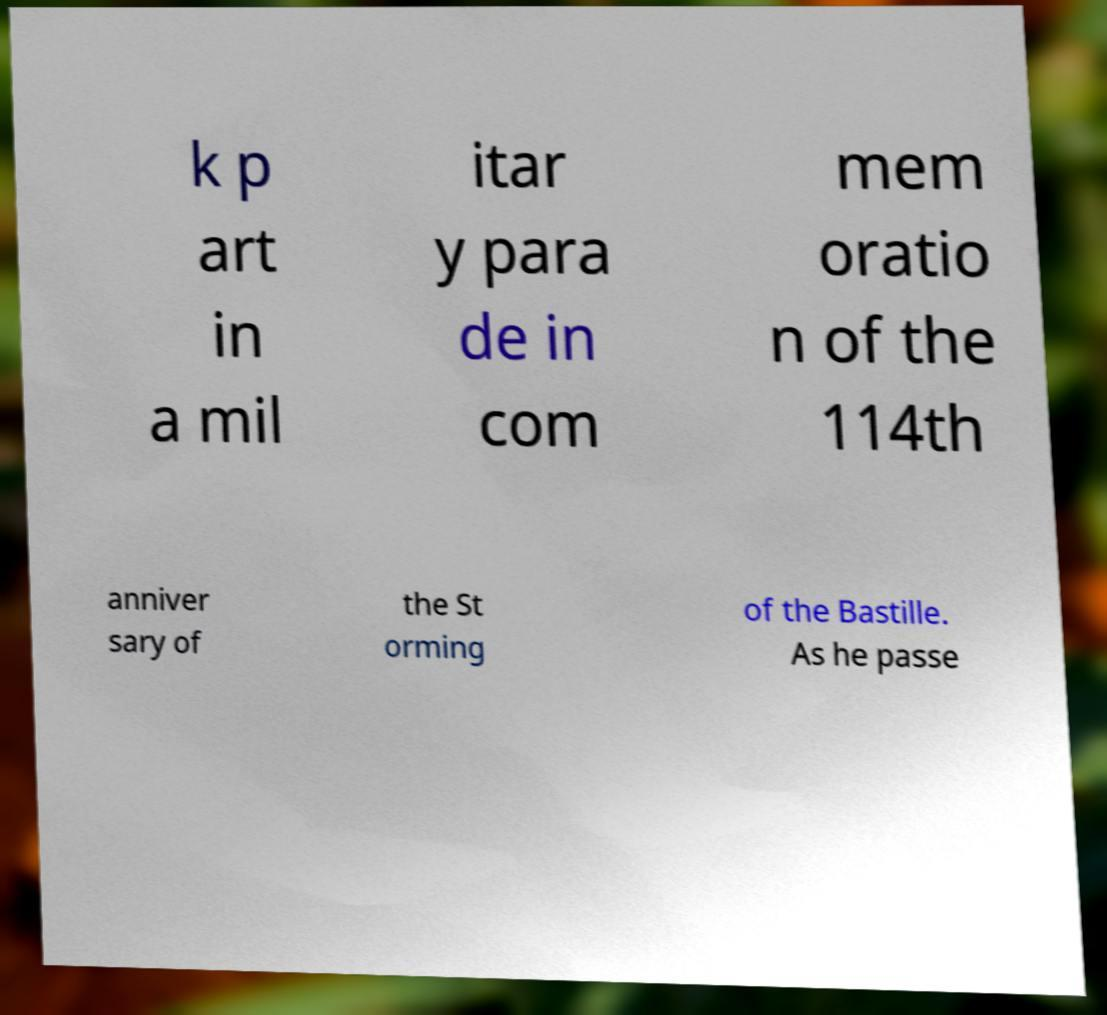Could you extract and type out the text from this image? k p art in a mil itar y para de in com mem oratio n of the 114th anniver sary of the St orming of the Bastille. As he passe 